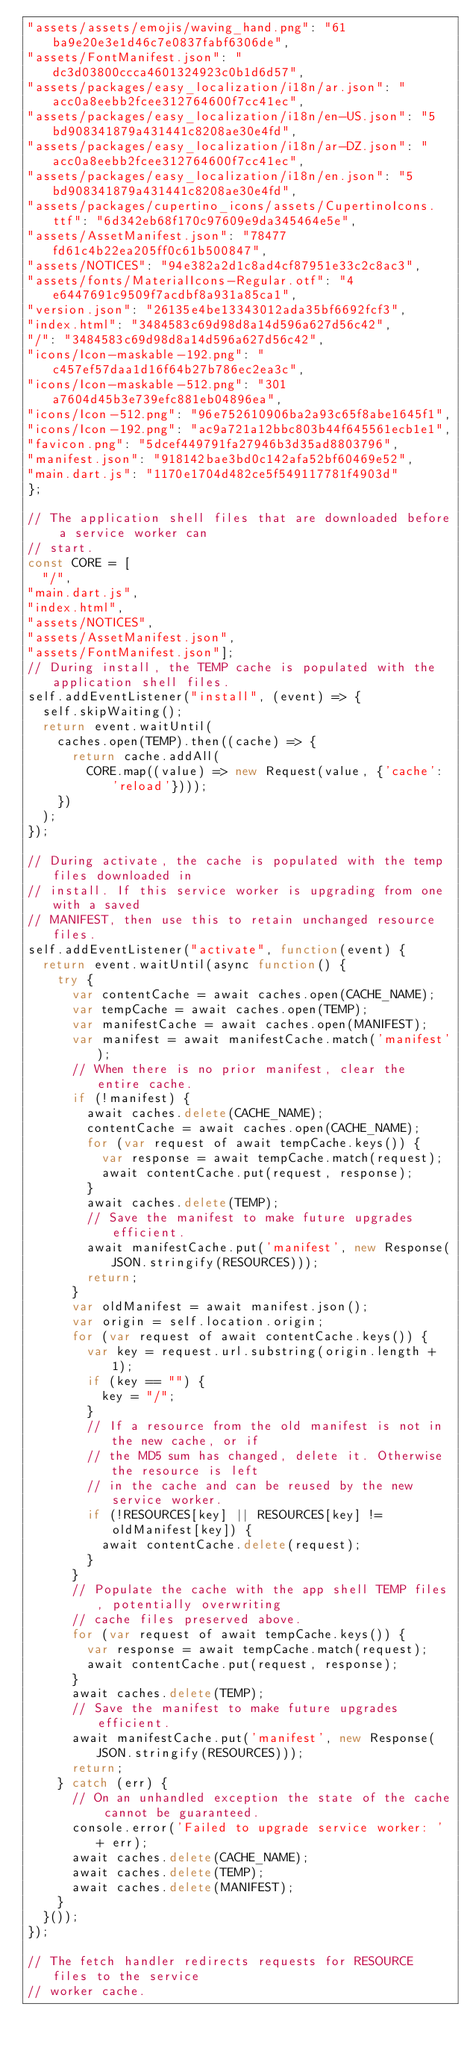Convert code to text. <code><loc_0><loc_0><loc_500><loc_500><_JavaScript_>"assets/assets/emojis/waving_hand.png": "61ba9e20e3e1d46c7e0837fabf6306de",
"assets/FontManifest.json": "dc3d03800ccca4601324923c0b1d6d57",
"assets/packages/easy_localization/i18n/ar.json": "acc0a8eebb2fcee312764600f7cc41ec",
"assets/packages/easy_localization/i18n/en-US.json": "5bd908341879a431441c8208ae30e4fd",
"assets/packages/easy_localization/i18n/ar-DZ.json": "acc0a8eebb2fcee312764600f7cc41ec",
"assets/packages/easy_localization/i18n/en.json": "5bd908341879a431441c8208ae30e4fd",
"assets/packages/cupertino_icons/assets/CupertinoIcons.ttf": "6d342eb68f170c97609e9da345464e5e",
"assets/AssetManifest.json": "78477fd61c4b22ea205ff0c61b500847",
"assets/NOTICES": "94e382a2d1c8ad4cf87951e33c2c8ac3",
"assets/fonts/MaterialIcons-Regular.otf": "4e6447691c9509f7acdbf8a931a85ca1",
"version.json": "26135e4be13343012ada35bf6692fcf3",
"index.html": "3484583c69d98d8a14d596a627d56c42",
"/": "3484583c69d98d8a14d596a627d56c42",
"icons/Icon-maskable-192.png": "c457ef57daa1d16f64b27b786ec2ea3c",
"icons/Icon-maskable-512.png": "301a7604d45b3e739efc881eb04896ea",
"icons/Icon-512.png": "96e752610906ba2a93c65f8abe1645f1",
"icons/Icon-192.png": "ac9a721a12bbc803b44f645561ecb1e1",
"favicon.png": "5dcef449791fa27946b3d35ad8803796",
"manifest.json": "918142bae3bd0c142afa52bf60469e52",
"main.dart.js": "1170e1704d482ce5f549117781f4903d"
};

// The application shell files that are downloaded before a service worker can
// start.
const CORE = [
  "/",
"main.dart.js",
"index.html",
"assets/NOTICES",
"assets/AssetManifest.json",
"assets/FontManifest.json"];
// During install, the TEMP cache is populated with the application shell files.
self.addEventListener("install", (event) => {
  self.skipWaiting();
  return event.waitUntil(
    caches.open(TEMP).then((cache) => {
      return cache.addAll(
        CORE.map((value) => new Request(value, {'cache': 'reload'})));
    })
  );
});

// During activate, the cache is populated with the temp files downloaded in
// install. If this service worker is upgrading from one with a saved
// MANIFEST, then use this to retain unchanged resource files.
self.addEventListener("activate", function(event) {
  return event.waitUntil(async function() {
    try {
      var contentCache = await caches.open(CACHE_NAME);
      var tempCache = await caches.open(TEMP);
      var manifestCache = await caches.open(MANIFEST);
      var manifest = await manifestCache.match('manifest');
      // When there is no prior manifest, clear the entire cache.
      if (!manifest) {
        await caches.delete(CACHE_NAME);
        contentCache = await caches.open(CACHE_NAME);
        for (var request of await tempCache.keys()) {
          var response = await tempCache.match(request);
          await contentCache.put(request, response);
        }
        await caches.delete(TEMP);
        // Save the manifest to make future upgrades efficient.
        await manifestCache.put('manifest', new Response(JSON.stringify(RESOURCES)));
        return;
      }
      var oldManifest = await manifest.json();
      var origin = self.location.origin;
      for (var request of await contentCache.keys()) {
        var key = request.url.substring(origin.length + 1);
        if (key == "") {
          key = "/";
        }
        // If a resource from the old manifest is not in the new cache, or if
        // the MD5 sum has changed, delete it. Otherwise the resource is left
        // in the cache and can be reused by the new service worker.
        if (!RESOURCES[key] || RESOURCES[key] != oldManifest[key]) {
          await contentCache.delete(request);
        }
      }
      // Populate the cache with the app shell TEMP files, potentially overwriting
      // cache files preserved above.
      for (var request of await tempCache.keys()) {
        var response = await tempCache.match(request);
        await contentCache.put(request, response);
      }
      await caches.delete(TEMP);
      // Save the manifest to make future upgrades efficient.
      await manifestCache.put('manifest', new Response(JSON.stringify(RESOURCES)));
      return;
    } catch (err) {
      // On an unhandled exception the state of the cache cannot be guaranteed.
      console.error('Failed to upgrade service worker: ' + err);
      await caches.delete(CACHE_NAME);
      await caches.delete(TEMP);
      await caches.delete(MANIFEST);
    }
  }());
});

// The fetch handler redirects requests for RESOURCE files to the service
// worker cache.</code> 